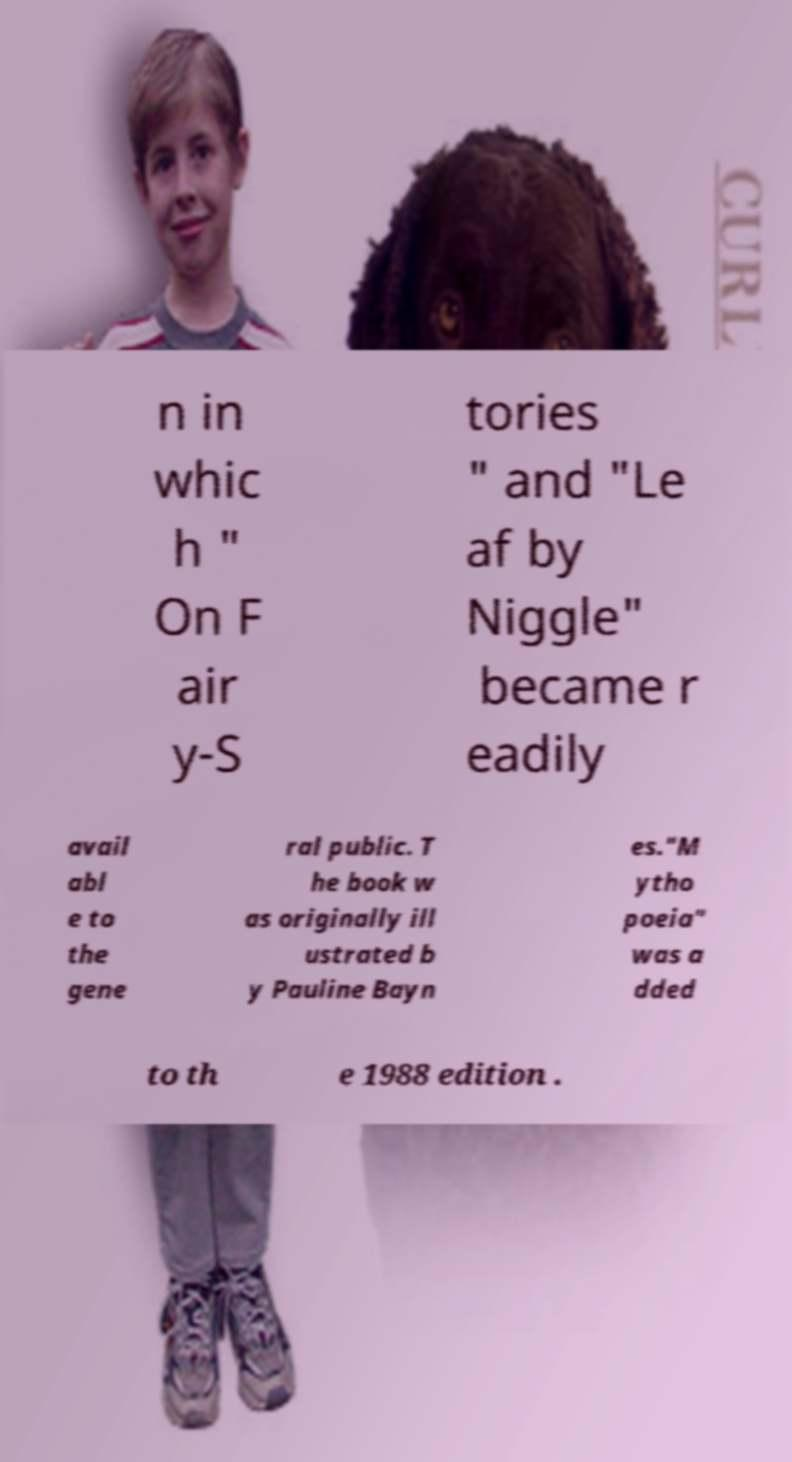What messages or text are displayed in this image? I need them in a readable, typed format. n in whic h " On F air y-S tories " and "Le af by Niggle" became r eadily avail abl e to the gene ral public. T he book w as originally ill ustrated b y Pauline Bayn es."M ytho poeia" was a dded to th e 1988 edition . 